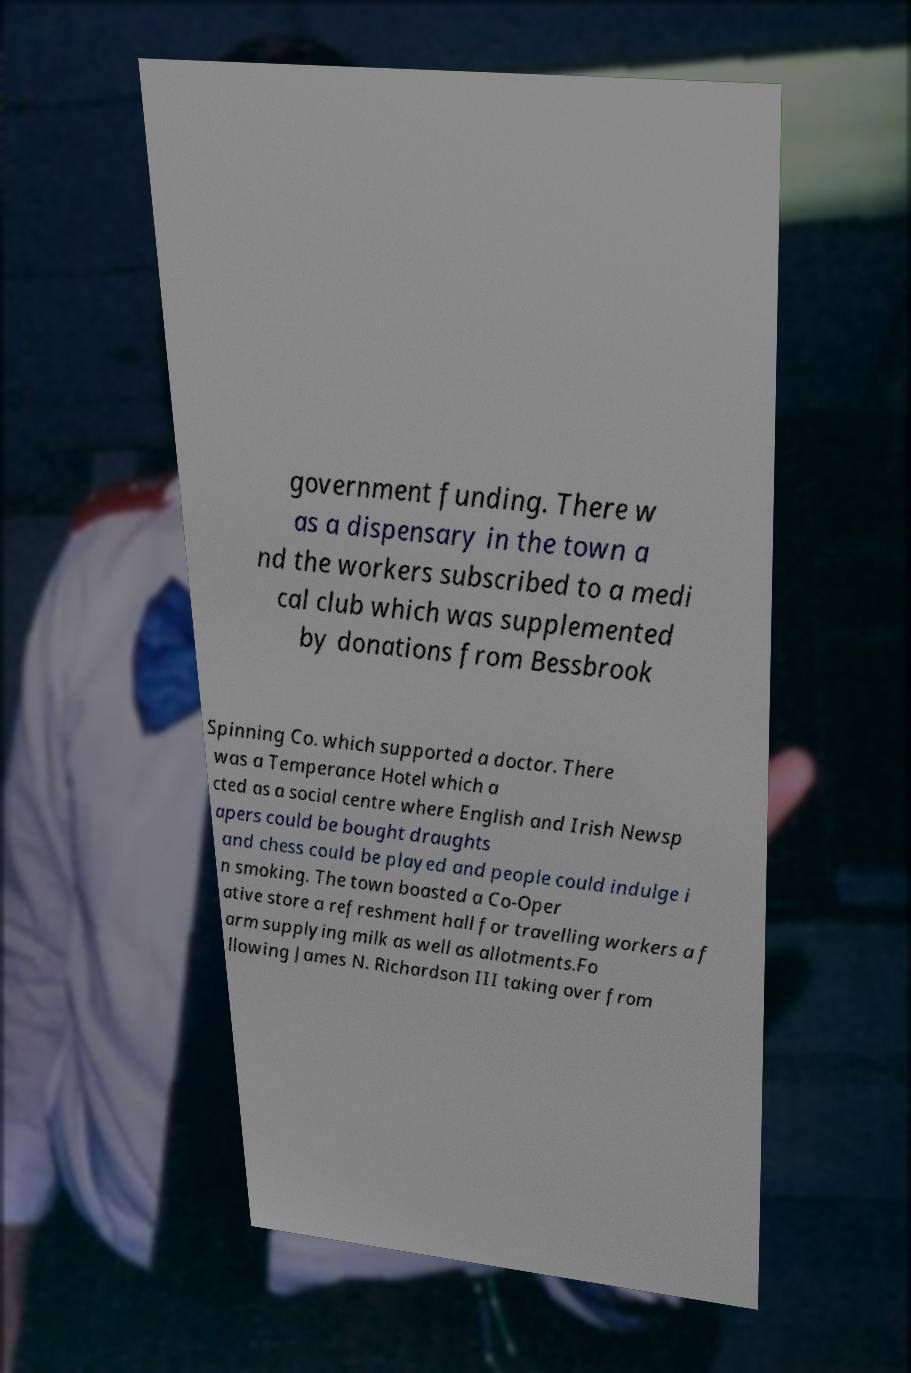There's text embedded in this image that I need extracted. Can you transcribe it verbatim? government funding. There w as a dispensary in the town a nd the workers subscribed to a medi cal club which was supplemented by donations from Bessbrook Spinning Co. which supported a doctor. There was a Temperance Hotel which a cted as a social centre where English and Irish Newsp apers could be bought draughts and chess could be played and people could indulge i n smoking. The town boasted a Co-Oper ative store a refreshment hall for travelling workers a f arm supplying milk as well as allotments.Fo llowing James N. Richardson III taking over from 